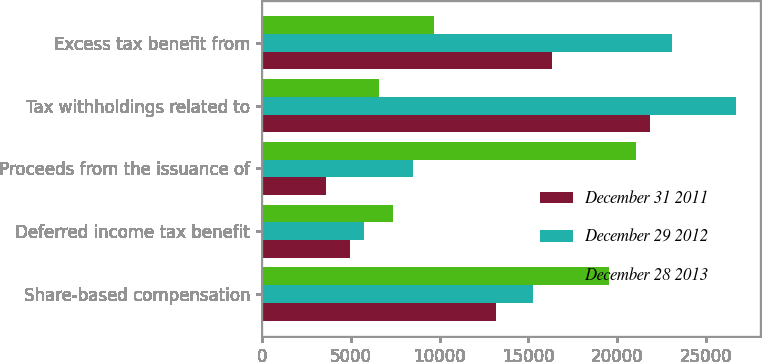<chart> <loc_0><loc_0><loc_500><loc_500><stacked_bar_chart><ecel><fcel>Share-based compensation<fcel>Deferred income tax benefit<fcel>Proceeds from the issuance of<fcel>Tax withholdings related to<fcel>Excess tax benefit from<nl><fcel>December 31 2011<fcel>13191<fcel>4991<fcel>3611<fcel>21856<fcel>16320<nl><fcel>December 29 2012<fcel>15236<fcel>5774<fcel>8495<fcel>26677<fcel>23099<nl><fcel>December 28 2013<fcel>19553<fcel>7411<fcel>21056<fcel>6582<fcel>9663<nl></chart> 